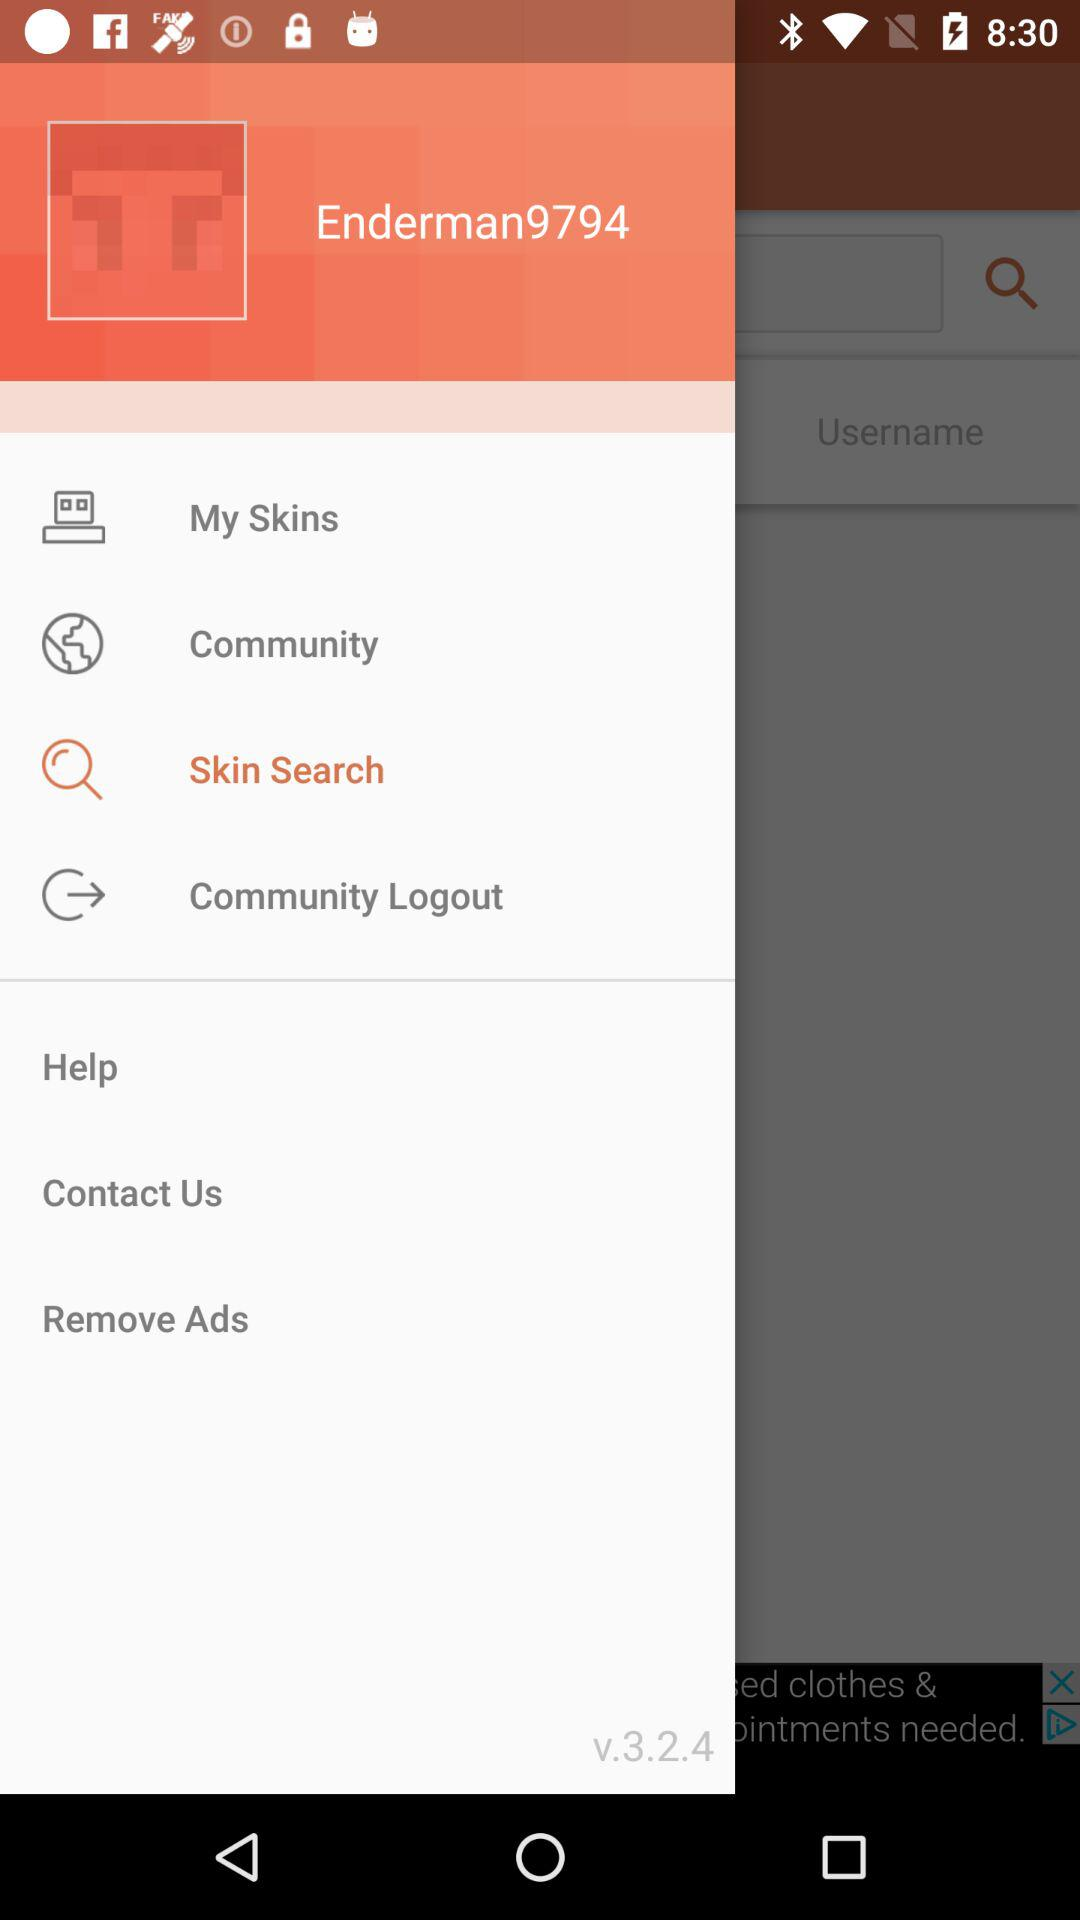What is the username? The username is "Enderman9794". 